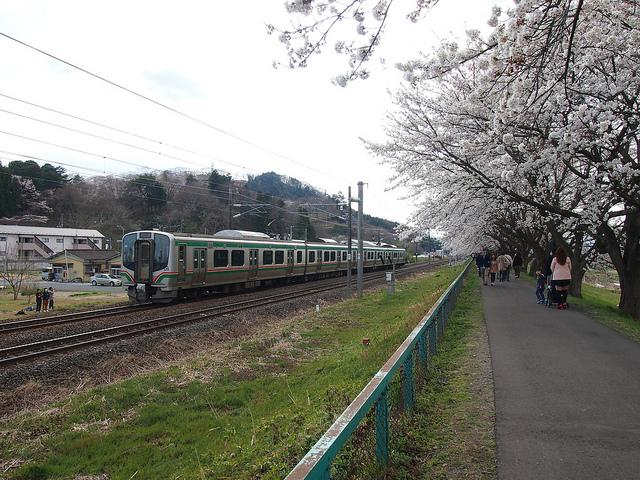What type of socks is the woman pushing the stroller wearing?

Choices:
A) ankle
B) knee-high
C) white
D) crew cut knee-high 